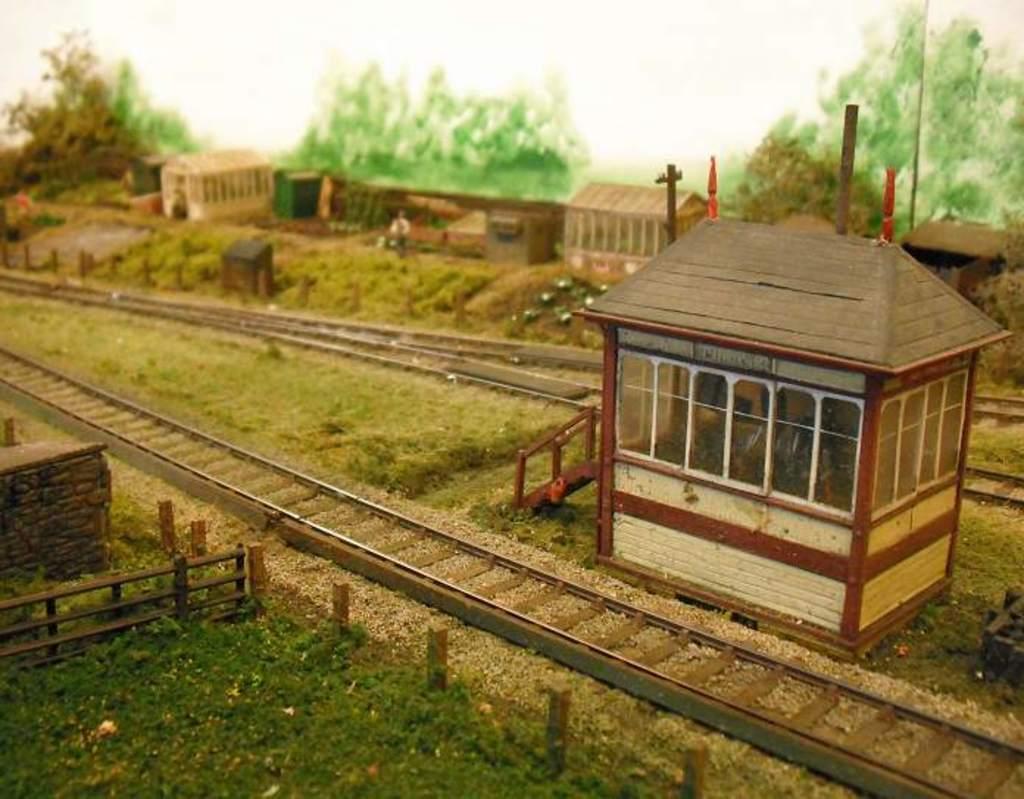In one or two sentences, can you explain what this image depicts? In this image there are shelters, poles, trees, grass, railing, tracks and objects. 